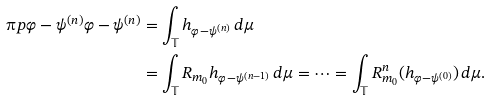Convert formula to latex. <formula><loc_0><loc_0><loc_500><loc_500>\i p { \varphi - \psi ^ { ( n ) } } { \varphi - \psi ^ { ( n ) } } & = \int _ { \mathbb { T } } h _ { \varphi - \psi ^ { ( n ) } } \, d \mu \\ & = \int _ { \mathbb { T } } R _ { m _ { 0 } } h _ { \varphi - \psi ^ { ( n - 1 ) } } \, d \mu = \dots = \int _ { \mathbb { T } } R _ { m _ { 0 } } ^ { n } ( h _ { \varphi - \psi ^ { ( 0 ) } } ) \, d \mu .</formula> 